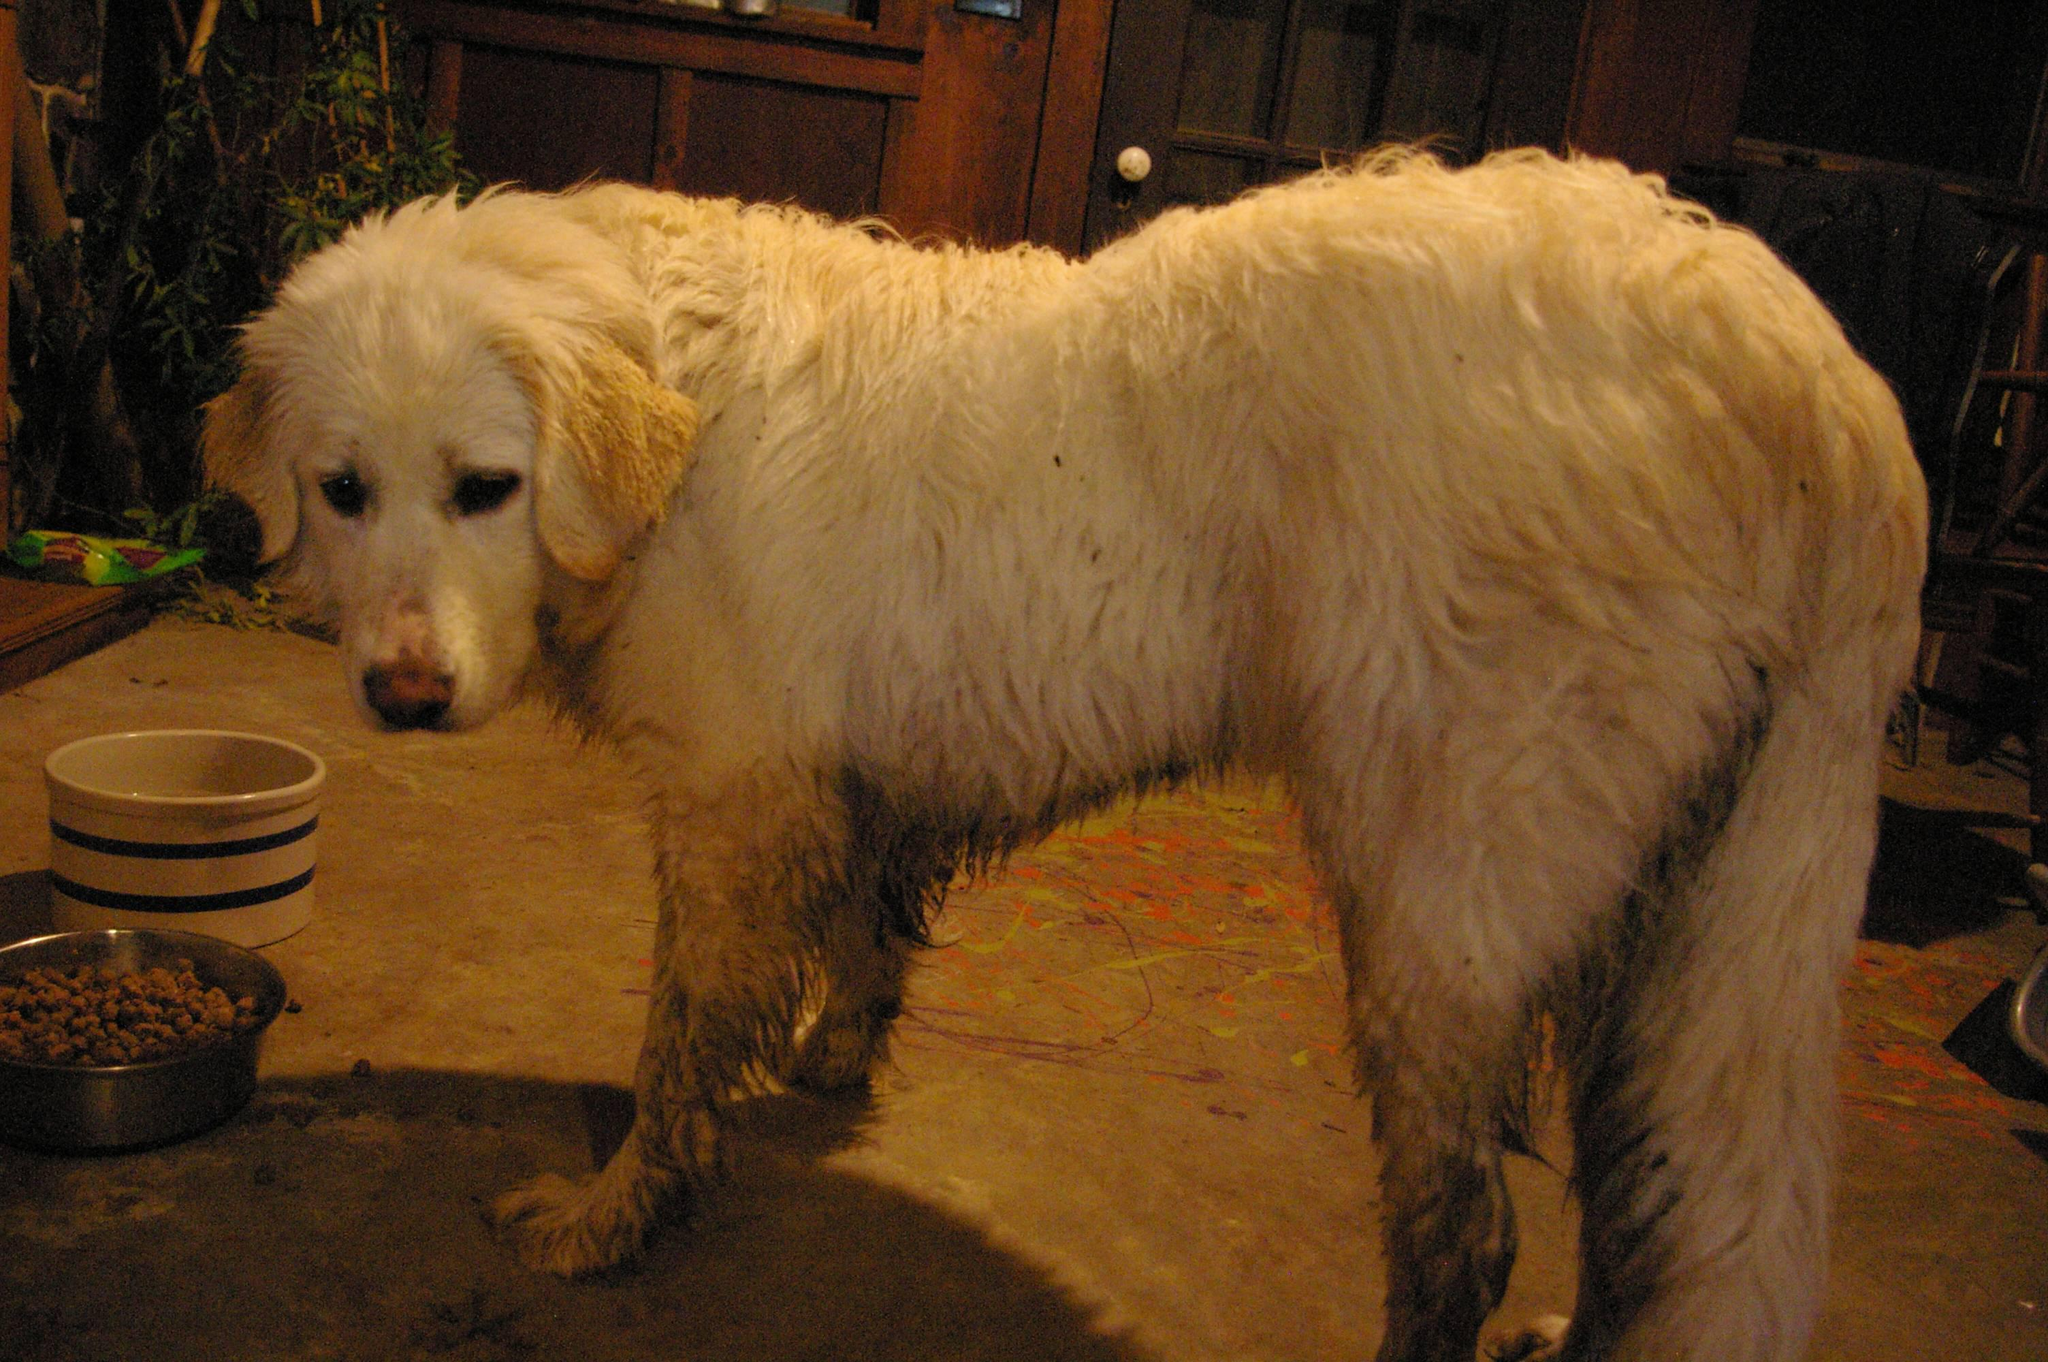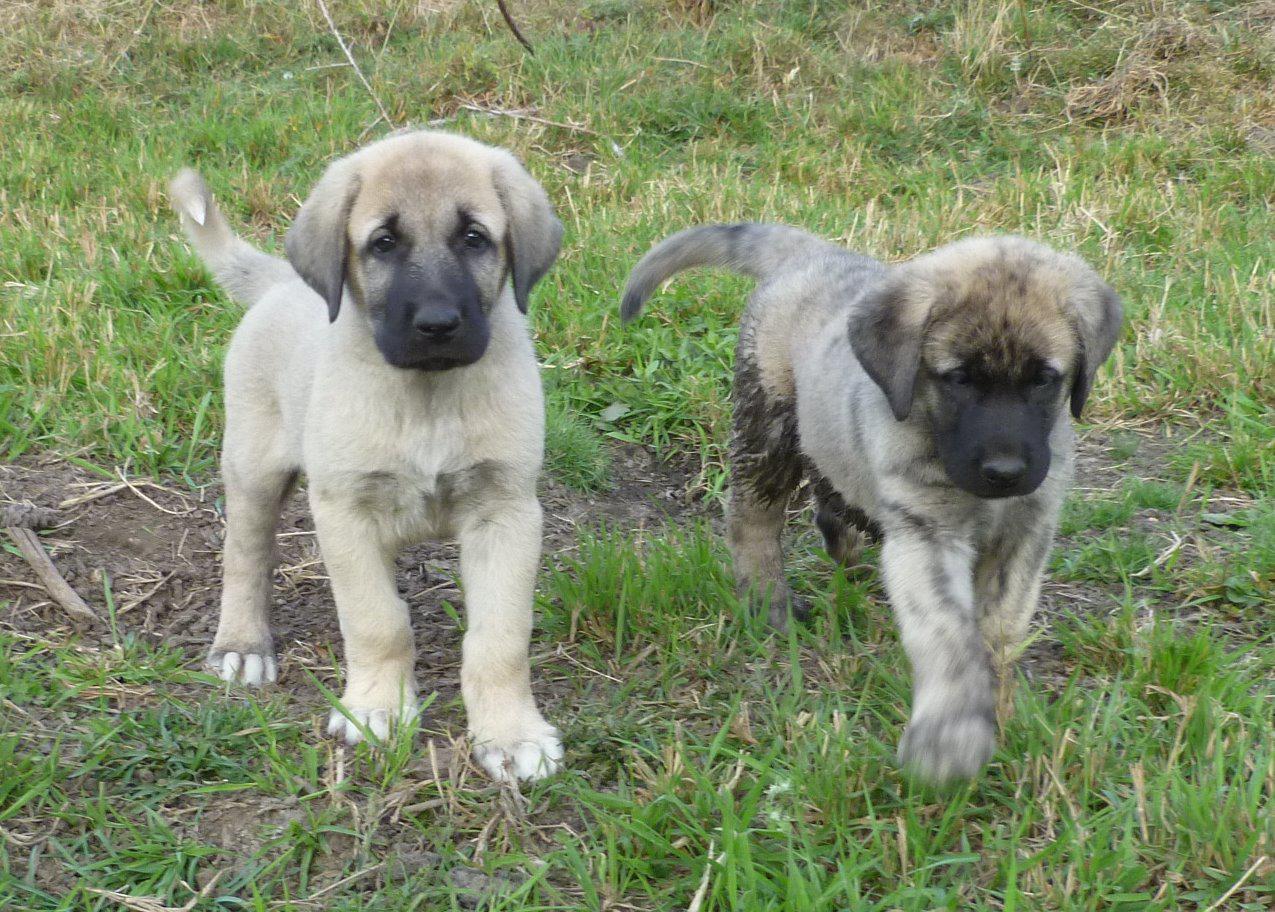The first image is the image on the left, the second image is the image on the right. For the images displayed, is the sentence "In at least one of the images, the dog is inside." factually correct? Answer yes or no. Yes. 